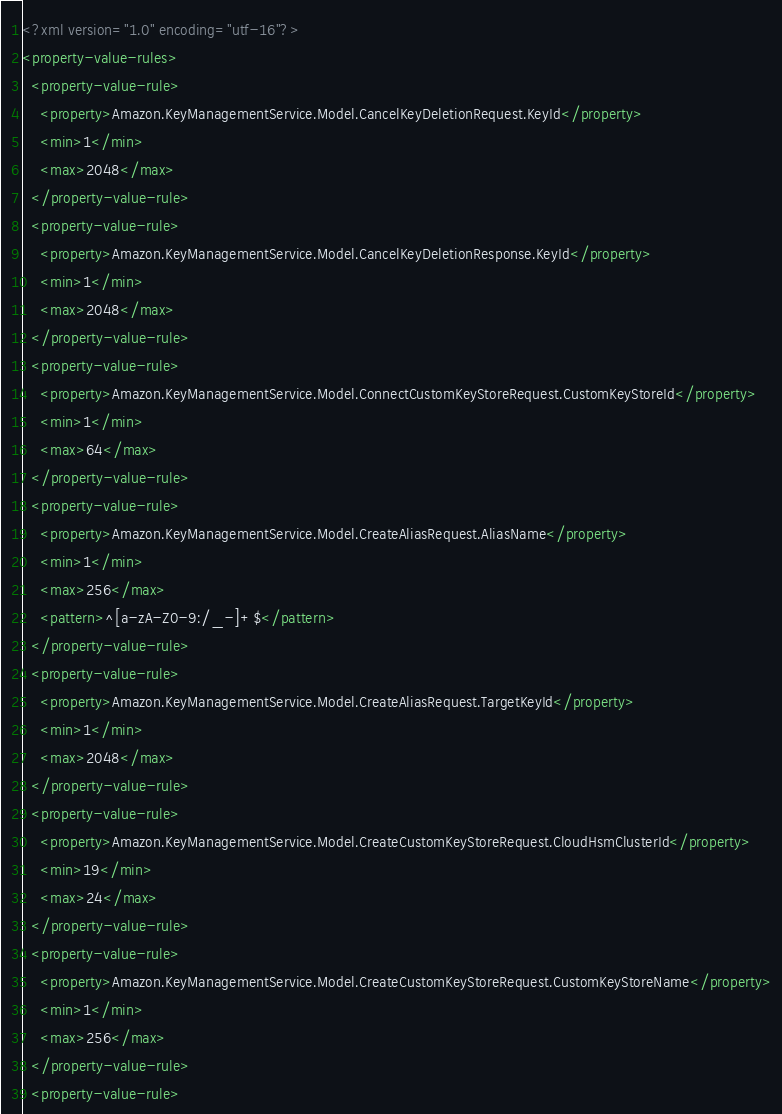<code> <loc_0><loc_0><loc_500><loc_500><_XML_><?xml version="1.0" encoding="utf-16"?>
<property-value-rules>
  <property-value-rule>
    <property>Amazon.KeyManagementService.Model.CancelKeyDeletionRequest.KeyId</property>
    <min>1</min>
    <max>2048</max>
  </property-value-rule>
  <property-value-rule>
    <property>Amazon.KeyManagementService.Model.CancelKeyDeletionResponse.KeyId</property>
    <min>1</min>
    <max>2048</max>
  </property-value-rule>
  <property-value-rule>
    <property>Amazon.KeyManagementService.Model.ConnectCustomKeyStoreRequest.CustomKeyStoreId</property>
    <min>1</min>
    <max>64</max>
  </property-value-rule>
  <property-value-rule>
    <property>Amazon.KeyManagementService.Model.CreateAliasRequest.AliasName</property>
    <min>1</min>
    <max>256</max>
    <pattern>^[a-zA-Z0-9:/_-]+$</pattern>
  </property-value-rule>
  <property-value-rule>
    <property>Amazon.KeyManagementService.Model.CreateAliasRequest.TargetKeyId</property>
    <min>1</min>
    <max>2048</max>
  </property-value-rule>
  <property-value-rule>
    <property>Amazon.KeyManagementService.Model.CreateCustomKeyStoreRequest.CloudHsmClusterId</property>
    <min>19</min>
    <max>24</max>
  </property-value-rule>
  <property-value-rule>
    <property>Amazon.KeyManagementService.Model.CreateCustomKeyStoreRequest.CustomKeyStoreName</property>
    <min>1</min>
    <max>256</max>
  </property-value-rule>
  <property-value-rule></code> 